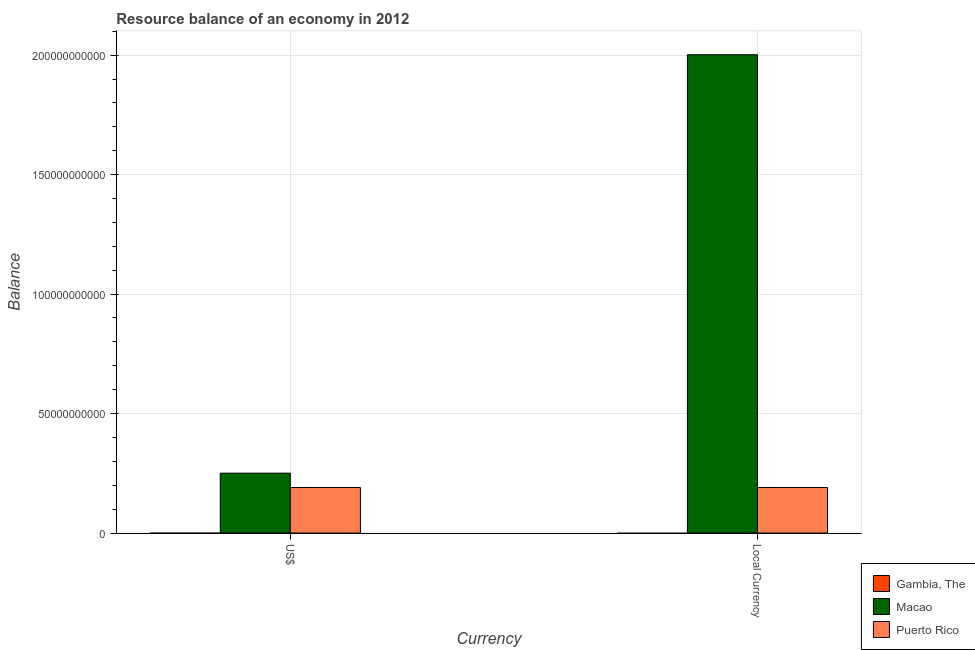How many different coloured bars are there?
Provide a short and direct response. 2. Are the number of bars per tick equal to the number of legend labels?
Offer a terse response. No. Are the number of bars on each tick of the X-axis equal?
Give a very brief answer. Yes. What is the label of the 2nd group of bars from the left?
Give a very brief answer. Local Currency. What is the resource balance in us$ in Macao?
Offer a terse response. 2.51e+1. Across all countries, what is the maximum resource balance in us$?
Give a very brief answer. 2.51e+1. In which country was the resource balance in constant us$ maximum?
Give a very brief answer. Macao. What is the total resource balance in us$ in the graph?
Offer a very short reply. 4.41e+1. What is the difference between the resource balance in constant us$ in Puerto Rico and that in Macao?
Provide a short and direct response. -1.81e+11. What is the difference between the resource balance in constant us$ in Gambia, The and the resource balance in us$ in Macao?
Your answer should be compact. -2.51e+1. What is the average resource balance in constant us$ per country?
Keep it short and to the point. 7.31e+1. What is the ratio of the resource balance in us$ in Macao to that in Puerto Rico?
Provide a succinct answer. 1.31. Are all the bars in the graph horizontal?
Provide a short and direct response. No. Does the graph contain grids?
Make the answer very short. Yes. Where does the legend appear in the graph?
Keep it short and to the point. Bottom right. How many legend labels are there?
Your answer should be very brief. 3. What is the title of the graph?
Your response must be concise. Resource balance of an economy in 2012. What is the label or title of the X-axis?
Make the answer very short. Currency. What is the label or title of the Y-axis?
Offer a very short reply. Balance. What is the Balance in Macao in US$?
Provide a short and direct response. 2.51e+1. What is the Balance in Puerto Rico in US$?
Your answer should be very brief. 1.91e+1. What is the Balance of Gambia, The in Local Currency?
Your answer should be compact. 0. What is the Balance in Macao in Local Currency?
Ensure brevity in your answer.  2.00e+11. What is the Balance in Puerto Rico in Local Currency?
Your response must be concise. 1.91e+1. Across all Currency, what is the maximum Balance in Macao?
Give a very brief answer. 2.00e+11. Across all Currency, what is the maximum Balance of Puerto Rico?
Ensure brevity in your answer.  1.91e+1. Across all Currency, what is the minimum Balance in Macao?
Your answer should be compact. 2.51e+1. Across all Currency, what is the minimum Balance of Puerto Rico?
Your answer should be very brief. 1.91e+1. What is the total Balance of Gambia, The in the graph?
Your response must be concise. 0. What is the total Balance in Macao in the graph?
Provide a short and direct response. 2.25e+11. What is the total Balance in Puerto Rico in the graph?
Provide a succinct answer. 3.81e+1. What is the difference between the Balance in Macao in US$ and that in Local Currency?
Ensure brevity in your answer.  -1.75e+11. What is the difference between the Balance of Puerto Rico in US$ and that in Local Currency?
Offer a terse response. 0. What is the difference between the Balance of Macao in US$ and the Balance of Puerto Rico in Local Currency?
Your answer should be very brief. 6.00e+09. What is the average Balance of Macao per Currency?
Keep it short and to the point. 1.13e+11. What is the average Balance in Puerto Rico per Currency?
Your answer should be very brief. 1.91e+1. What is the difference between the Balance in Macao and Balance in Puerto Rico in US$?
Provide a succinct answer. 6.00e+09. What is the difference between the Balance of Macao and Balance of Puerto Rico in Local Currency?
Provide a succinct answer. 1.81e+11. What is the ratio of the Balance in Macao in US$ to that in Local Currency?
Your answer should be very brief. 0.13. What is the difference between the highest and the second highest Balance of Macao?
Offer a very short reply. 1.75e+11. What is the difference between the highest and the second highest Balance of Puerto Rico?
Ensure brevity in your answer.  0. What is the difference between the highest and the lowest Balance in Macao?
Keep it short and to the point. 1.75e+11. What is the difference between the highest and the lowest Balance in Puerto Rico?
Your answer should be very brief. 0. 